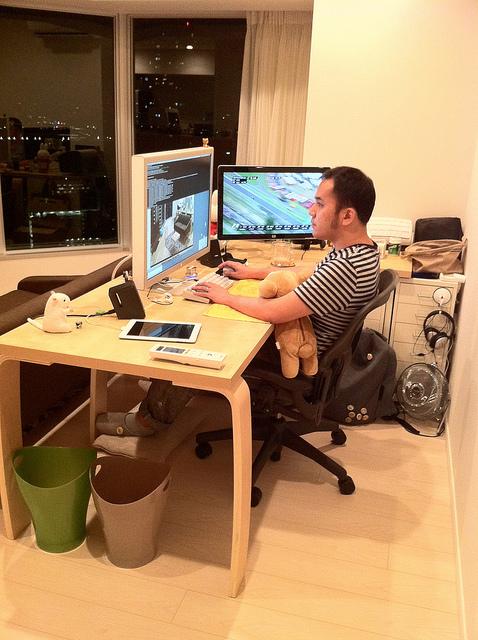How many monitors are on in this picture?
Keep it brief. 2. How many waste cans are there?
Short answer required. 2. What sort of computer is she using?
Keep it brief. Desktop. Is there a stuffed animal on his belly?
Concise answer only. Yes. 